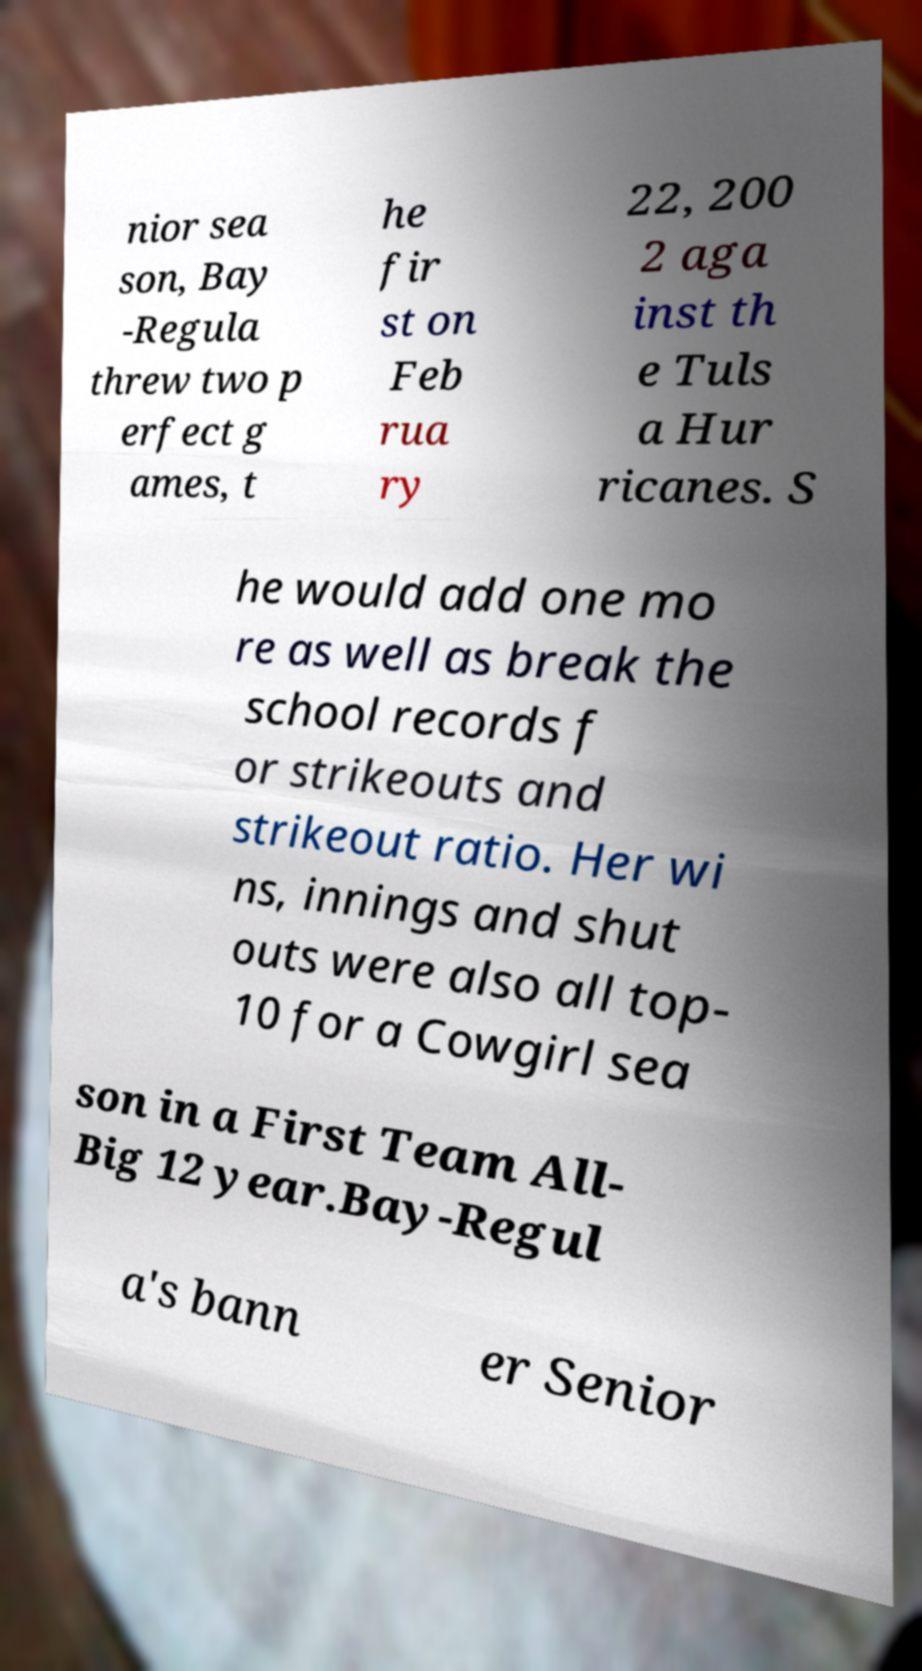I need the written content from this picture converted into text. Can you do that? nior sea son, Bay -Regula threw two p erfect g ames, t he fir st on Feb rua ry 22, 200 2 aga inst th e Tuls a Hur ricanes. S he would add one mo re as well as break the school records f or strikeouts and strikeout ratio. Her wi ns, innings and shut outs were also all top- 10 for a Cowgirl sea son in a First Team All- Big 12 year.Bay-Regul a's bann er Senior 